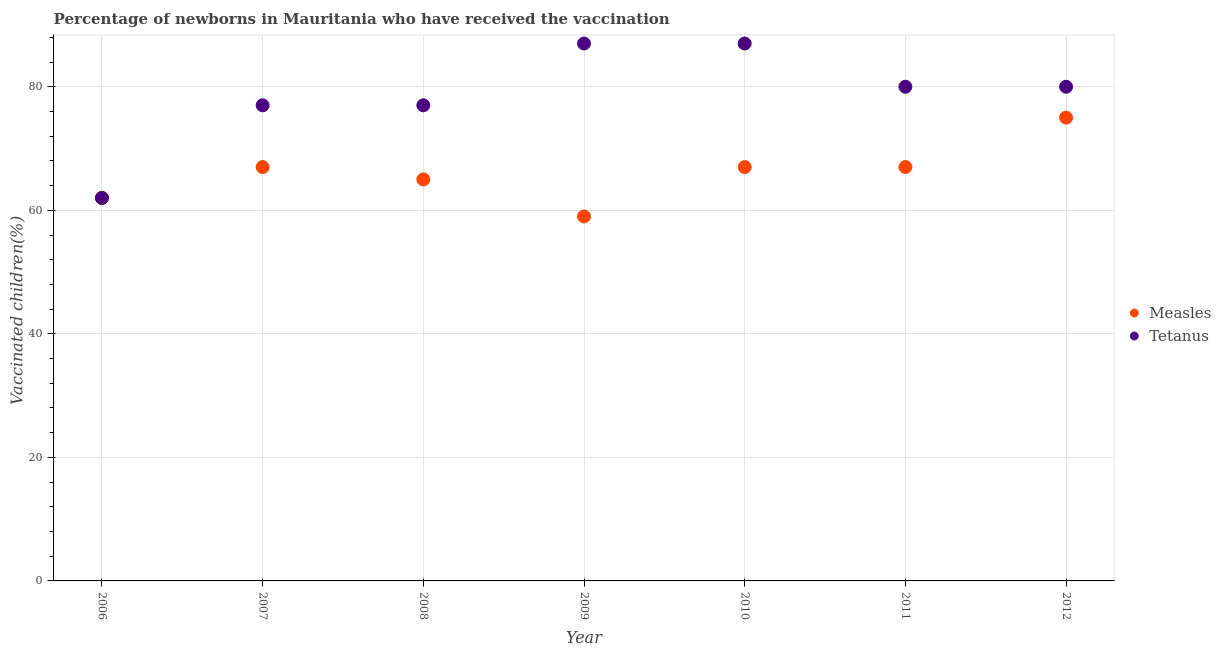What is the percentage of newborns who received vaccination for tetanus in 2008?
Keep it short and to the point. 77. Across all years, what is the maximum percentage of newborns who received vaccination for tetanus?
Provide a succinct answer. 87. Across all years, what is the minimum percentage of newborns who received vaccination for tetanus?
Offer a very short reply. 62. In which year was the percentage of newborns who received vaccination for tetanus minimum?
Ensure brevity in your answer.  2006. What is the total percentage of newborns who received vaccination for measles in the graph?
Keep it short and to the point. 462. What is the difference between the percentage of newborns who received vaccination for tetanus in 2007 and that in 2011?
Keep it short and to the point. -3. What is the difference between the percentage of newborns who received vaccination for measles in 2006 and the percentage of newborns who received vaccination for tetanus in 2012?
Your answer should be compact. -18. What is the average percentage of newborns who received vaccination for tetanus per year?
Give a very brief answer. 78.57. In the year 2009, what is the difference between the percentage of newborns who received vaccination for tetanus and percentage of newborns who received vaccination for measles?
Offer a terse response. 28. What is the difference between the highest and the lowest percentage of newborns who received vaccination for tetanus?
Offer a very short reply. 25. In how many years, is the percentage of newborns who received vaccination for measles greater than the average percentage of newborns who received vaccination for measles taken over all years?
Give a very brief answer. 4. Is the percentage of newborns who received vaccination for measles strictly greater than the percentage of newborns who received vaccination for tetanus over the years?
Provide a short and direct response. No. Does the graph contain grids?
Ensure brevity in your answer.  Yes. Where does the legend appear in the graph?
Your response must be concise. Center right. How many legend labels are there?
Give a very brief answer. 2. What is the title of the graph?
Provide a short and direct response. Percentage of newborns in Mauritania who have received the vaccination. What is the label or title of the X-axis?
Offer a very short reply. Year. What is the label or title of the Y-axis?
Provide a succinct answer. Vaccinated children(%)
. What is the Vaccinated children(%)
 in Measles in 2006?
Offer a very short reply. 62. What is the Vaccinated children(%)
 of Tetanus in 2006?
Offer a very short reply. 62. What is the Vaccinated children(%)
 in Measles in 2010?
Ensure brevity in your answer.  67. What is the Vaccinated children(%)
 of Tetanus in 2010?
Your answer should be very brief. 87. What is the Vaccinated children(%)
 in Measles in 2011?
Offer a terse response. 67. What is the Vaccinated children(%)
 of Tetanus in 2011?
Keep it short and to the point. 80. What is the Vaccinated children(%)
 of Tetanus in 2012?
Give a very brief answer. 80. What is the total Vaccinated children(%)
 in Measles in the graph?
Offer a very short reply. 462. What is the total Vaccinated children(%)
 of Tetanus in the graph?
Make the answer very short. 550. What is the difference between the Vaccinated children(%)
 in Measles in 2006 and that in 2007?
Offer a terse response. -5. What is the difference between the Vaccinated children(%)
 of Measles in 2006 and that in 2009?
Your answer should be compact. 3. What is the difference between the Vaccinated children(%)
 of Measles in 2006 and that in 2011?
Your answer should be compact. -5. What is the difference between the Vaccinated children(%)
 in Tetanus in 2006 and that in 2011?
Your answer should be compact. -18. What is the difference between the Vaccinated children(%)
 in Tetanus in 2006 and that in 2012?
Ensure brevity in your answer.  -18. What is the difference between the Vaccinated children(%)
 in Measles in 2007 and that in 2009?
Your response must be concise. 8. What is the difference between the Vaccinated children(%)
 in Tetanus in 2007 and that in 2009?
Keep it short and to the point. -10. What is the difference between the Vaccinated children(%)
 of Measles in 2007 and that in 2010?
Your answer should be compact. 0. What is the difference between the Vaccinated children(%)
 of Tetanus in 2007 and that in 2010?
Offer a very short reply. -10. What is the difference between the Vaccinated children(%)
 in Tetanus in 2007 and that in 2011?
Your answer should be compact. -3. What is the difference between the Vaccinated children(%)
 of Measles in 2008 and that in 2009?
Offer a very short reply. 6. What is the difference between the Vaccinated children(%)
 of Tetanus in 2008 and that in 2009?
Ensure brevity in your answer.  -10. What is the difference between the Vaccinated children(%)
 in Measles in 2008 and that in 2010?
Offer a terse response. -2. What is the difference between the Vaccinated children(%)
 of Tetanus in 2008 and that in 2010?
Keep it short and to the point. -10. What is the difference between the Vaccinated children(%)
 of Tetanus in 2008 and that in 2011?
Your answer should be very brief. -3. What is the difference between the Vaccinated children(%)
 of Measles in 2008 and that in 2012?
Make the answer very short. -10. What is the difference between the Vaccinated children(%)
 of Tetanus in 2009 and that in 2010?
Offer a terse response. 0. What is the difference between the Vaccinated children(%)
 in Measles in 2009 and that in 2012?
Keep it short and to the point. -16. What is the difference between the Vaccinated children(%)
 in Tetanus in 2010 and that in 2011?
Ensure brevity in your answer.  7. What is the difference between the Vaccinated children(%)
 of Tetanus in 2010 and that in 2012?
Make the answer very short. 7. What is the difference between the Vaccinated children(%)
 in Measles in 2011 and that in 2012?
Ensure brevity in your answer.  -8. What is the difference between the Vaccinated children(%)
 of Tetanus in 2011 and that in 2012?
Make the answer very short. 0. What is the difference between the Vaccinated children(%)
 in Measles in 2006 and the Vaccinated children(%)
 in Tetanus in 2007?
Your answer should be very brief. -15. What is the difference between the Vaccinated children(%)
 of Measles in 2006 and the Vaccinated children(%)
 of Tetanus in 2009?
Give a very brief answer. -25. What is the difference between the Vaccinated children(%)
 of Measles in 2006 and the Vaccinated children(%)
 of Tetanus in 2010?
Keep it short and to the point. -25. What is the difference between the Vaccinated children(%)
 of Measles in 2006 and the Vaccinated children(%)
 of Tetanus in 2012?
Keep it short and to the point. -18. What is the difference between the Vaccinated children(%)
 of Measles in 2007 and the Vaccinated children(%)
 of Tetanus in 2009?
Your response must be concise. -20. What is the difference between the Vaccinated children(%)
 of Measles in 2007 and the Vaccinated children(%)
 of Tetanus in 2011?
Your answer should be compact. -13. What is the difference between the Vaccinated children(%)
 of Measles in 2007 and the Vaccinated children(%)
 of Tetanus in 2012?
Ensure brevity in your answer.  -13. What is the difference between the Vaccinated children(%)
 of Measles in 2008 and the Vaccinated children(%)
 of Tetanus in 2009?
Offer a terse response. -22. What is the difference between the Vaccinated children(%)
 in Measles in 2008 and the Vaccinated children(%)
 in Tetanus in 2011?
Provide a short and direct response. -15. What is the difference between the Vaccinated children(%)
 of Measles in 2008 and the Vaccinated children(%)
 of Tetanus in 2012?
Offer a terse response. -15. What is the difference between the Vaccinated children(%)
 of Measles in 2009 and the Vaccinated children(%)
 of Tetanus in 2010?
Provide a short and direct response. -28. What is the difference between the Vaccinated children(%)
 of Measles in 2009 and the Vaccinated children(%)
 of Tetanus in 2011?
Give a very brief answer. -21. What is the difference between the Vaccinated children(%)
 in Measles in 2009 and the Vaccinated children(%)
 in Tetanus in 2012?
Your answer should be very brief. -21. What is the difference between the Vaccinated children(%)
 of Measles in 2011 and the Vaccinated children(%)
 of Tetanus in 2012?
Provide a short and direct response. -13. What is the average Vaccinated children(%)
 in Measles per year?
Offer a terse response. 66. What is the average Vaccinated children(%)
 of Tetanus per year?
Your response must be concise. 78.57. In the year 2007, what is the difference between the Vaccinated children(%)
 in Measles and Vaccinated children(%)
 in Tetanus?
Keep it short and to the point. -10. In the year 2008, what is the difference between the Vaccinated children(%)
 of Measles and Vaccinated children(%)
 of Tetanus?
Your response must be concise. -12. In the year 2012, what is the difference between the Vaccinated children(%)
 of Measles and Vaccinated children(%)
 of Tetanus?
Keep it short and to the point. -5. What is the ratio of the Vaccinated children(%)
 of Measles in 2006 to that in 2007?
Your response must be concise. 0.93. What is the ratio of the Vaccinated children(%)
 of Tetanus in 2006 to that in 2007?
Offer a very short reply. 0.81. What is the ratio of the Vaccinated children(%)
 in Measles in 2006 to that in 2008?
Your answer should be compact. 0.95. What is the ratio of the Vaccinated children(%)
 in Tetanus in 2006 to that in 2008?
Your answer should be very brief. 0.81. What is the ratio of the Vaccinated children(%)
 in Measles in 2006 to that in 2009?
Your answer should be very brief. 1.05. What is the ratio of the Vaccinated children(%)
 in Tetanus in 2006 to that in 2009?
Ensure brevity in your answer.  0.71. What is the ratio of the Vaccinated children(%)
 in Measles in 2006 to that in 2010?
Your answer should be compact. 0.93. What is the ratio of the Vaccinated children(%)
 of Tetanus in 2006 to that in 2010?
Provide a succinct answer. 0.71. What is the ratio of the Vaccinated children(%)
 of Measles in 2006 to that in 2011?
Provide a short and direct response. 0.93. What is the ratio of the Vaccinated children(%)
 of Tetanus in 2006 to that in 2011?
Your answer should be compact. 0.78. What is the ratio of the Vaccinated children(%)
 of Measles in 2006 to that in 2012?
Provide a succinct answer. 0.83. What is the ratio of the Vaccinated children(%)
 of Tetanus in 2006 to that in 2012?
Ensure brevity in your answer.  0.78. What is the ratio of the Vaccinated children(%)
 of Measles in 2007 to that in 2008?
Offer a terse response. 1.03. What is the ratio of the Vaccinated children(%)
 of Measles in 2007 to that in 2009?
Offer a very short reply. 1.14. What is the ratio of the Vaccinated children(%)
 in Tetanus in 2007 to that in 2009?
Provide a short and direct response. 0.89. What is the ratio of the Vaccinated children(%)
 in Tetanus in 2007 to that in 2010?
Give a very brief answer. 0.89. What is the ratio of the Vaccinated children(%)
 of Measles in 2007 to that in 2011?
Offer a terse response. 1. What is the ratio of the Vaccinated children(%)
 of Tetanus in 2007 to that in 2011?
Your answer should be very brief. 0.96. What is the ratio of the Vaccinated children(%)
 in Measles in 2007 to that in 2012?
Ensure brevity in your answer.  0.89. What is the ratio of the Vaccinated children(%)
 of Tetanus in 2007 to that in 2012?
Provide a short and direct response. 0.96. What is the ratio of the Vaccinated children(%)
 in Measles in 2008 to that in 2009?
Your answer should be compact. 1.1. What is the ratio of the Vaccinated children(%)
 of Tetanus in 2008 to that in 2009?
Provide a succinct answer. 0.89. What is the ratio of the Vaccinated children(%)
 in Measles in 2008 to that in 2010?
Ensure brevity in your answer.  0.97. What is the ratio of the Vaccinated children(%)
 of Tetanus in 2008 to that in 2010?
Make the answer very short. 0.89. What is the ratio of the Vaccinated children(%)
 in Measles in 2008 to that in 2011?
Ensure brevity in your answer.  0.97. What is the ratio of the Vaccinated children(%)
 of Tetanus in 2008 to that in 2011?
Give a very brief answer. 0.96. What is the ratio of the Vaccinated children(%)
 of Measles in 2008 to that in 2012?
Offer a terse response. 0.87. What is the ratio of the Vaccinated children(%)
 of Tetanus in 2008 to that in 2012?
Offer a very short reply. 0.96. What is the ratio of the Vaccinated children(%)
 in Measles in 2009 to that in 2010?
Keep it short and to the point. 0.88. What is the ratio of the Vaccinated children(%)
 in Measles in 2009 to that in 2011?
Your answer should be very brief. 0.88. What is the ratio of the Vaccinated children(%)
 in Tetanus in 2009 to that in 2011?
Provide a short and direct response. 1.09. What is the ratio of the Vaccinated children(%)
 of Measles in 2009 to that in 2012?
Ensure brevity in your answer.  0.79. What is the ratio of the Vaccinated children(%)
 in Tetanus in 2009 to that in 2012?
Give a very brief answer. 1.09. What is the ratio of the Vaccinated children(%)
 in Tetanus in 2010 to that in 2011?
Ensure brevity in your answer.  1.09. What is the ratio of the Vaccinated children(%)
 in Measles in 2010 to that in 2012?
Provide a short and direct response. 0.89. What is the ratio of the Vaccinated children(%)
 in Tetanus in 2010 to that in 2012?
Your response must be concise. 1.09. What is the ratio of the Vaccinated children(%)
 of Measles in 2011 to that in 2012?
Make the answer very short. 0.89. What is the ratio of the Vaccinated children(%)
 in Tetanus in 2011 to that in 2012?
Keep it short and to the point. 1. What is the difference between the highest and the second highest Vaccinated children(%)
 in Measles?
Offer a terse response. 8. What is the difference between the highest and the second highest Vaccinated children(%)
 of Tetanus?
Your response must be concise. 0. What is the difference between the highest and the lowest Vaccinated children(%)
 in Measles?
Your answer should be very brief. 16. 